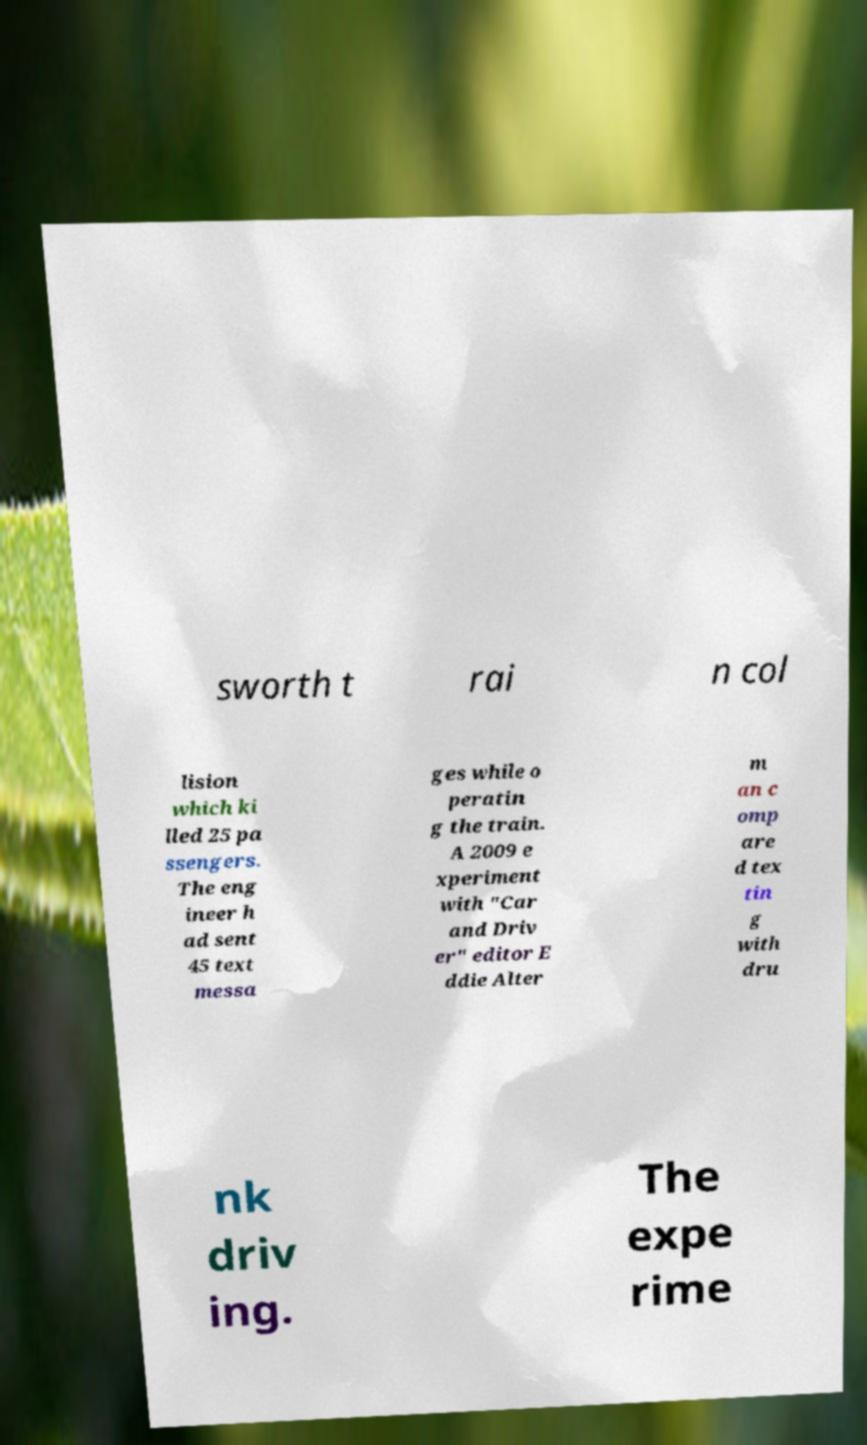Can you read and provide the text displayed in the image?This photo seems to have some interesting text. Can you extract and type it out for me? sworth t rai n col lision which ki lled 25 pa ssengers. The eng ineer h ad sent 45 text messa ges while o peratin g the train. A 2009 e xperiment with "Car and Driv er" editor E ddie Alter m an c omp are d tex tin g with dru nk driv ing. The expe rime 